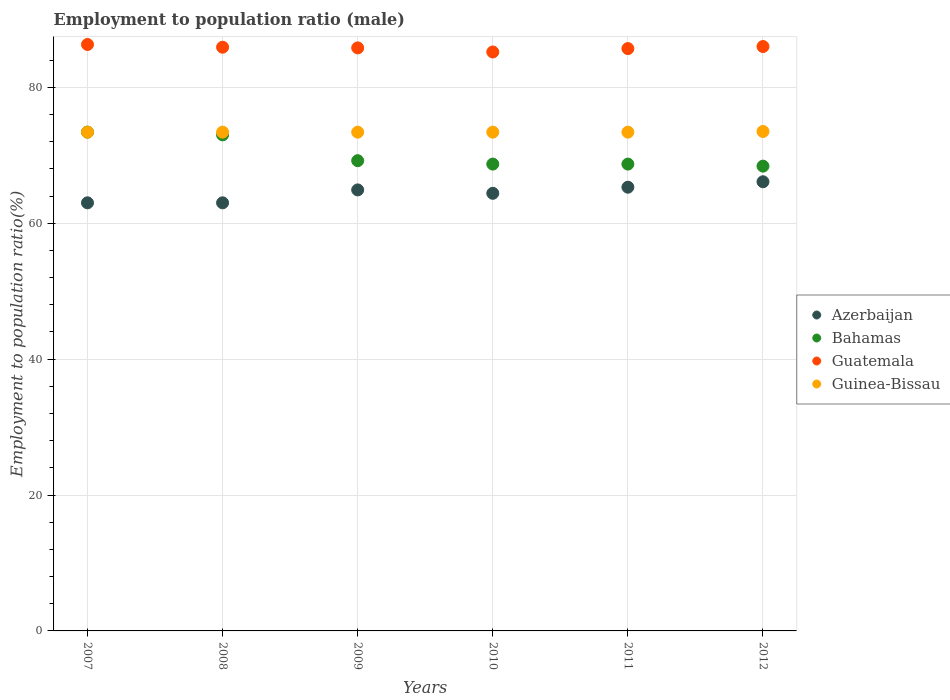Is the number of dotlines equal to the number of legend labels?
Your answer should be very brief. Yes. What is the employment to population ratio in Guatemala in 2008?
Keep it short and to the point. 85.9. Across all years, what is the maximum employment to population ratio in Guatemala?
Provide a succinct answer. 86.3. Across all years, what is the minimum employment to population ratio in Guinea-Bissau?
Give a very brief answer. 73.4. In which year was the employment to population ratio in Azerbaijan maximum?
Ensure brevity in your answer.  2012. In which year was the employment to population ratio in Azerbaijan minimum?
Your answer should be very brief. 2007. What is the total employment to population ratio in Bahamas in the graph?
Make the answer very short. 421.4. What is the difference between the employment to population ratio in Guinea-Bissau in 2007 and that in 2012?
Offer a terse response. -0.1. What is the difference between the employment to population ratio in Azerbaijan in 2010 and the employment to population ratio in Guatemala in 2008?
Ensure brevity in your answer.  -21.5. What is the average employment to population ratio in Azerbaijan per year?
Make the answer very short. 64.45. What is the ratio of the employment to population ratio in Azerbaijan in 2009 to that in 2012?
Offer a very short reply. 0.98. Is the employment to population ratio in Azerbaijan in 2009 less than that in 2011?
Your response must be concise. Yes. What is the difference between the highest and the second highest employment to population ratio in Guinea-Bissau?
Give a very brief answer. 0.1. What is the difference between the highest and the lowest employment to population ratio in Bahamas?
Your answer should be very brief. 5. Is the sum of the employment to population ratio in Guatemala in 2010 and 2012 greater than the maximum employment to population ratio in Guinea-Bissau across all years?
Offer a terse response. Yes. Is it the case that in every year, the sum of the employment to population ratio in Bahamas and employment to population ratio in Azerbaijan  is greater than the sum of employment to population ratio in Guinea-Bissau and employment to population ratio in Guatemala?
Ensure brevity in your answer.  No. Does the employment to population ratio in Bahamas monotonically increase over the years?
Your answer should be very brief. No. Is the employment to population ratio in Bahamas strictly less than the employment to population ratio in Azerbaijan over the years?
Give a very brief answer. No. How many dotlines are there?
Give a very brief answer. 4. How many years are there in the graph?
Make the answer very short. 6. What is the difference between two consecutive major ticks on the Y-axis?
Offer a terse response. 20. Where does the legend appear in the graph?
Provide a succinct answer. Center right. What is the title of the graph?
Your answer should be very brief. Employment to population ratio (male). What is the label or title of the Y-axis?
Offer a terse response. Employment to population ratio(%). What is the Employment to population ratio(%) of Azerbaijan in 2007?
Give a very brief answer. 63. What is the Employment to population ratio(%) in Bahamas in 2007?
Provide a succinct answer. 73.4. What is the Employment to population ratio(%) in Guatemala in 2007?
Provide a succinct answer. 86.3. What is the Employment to population ratio(%) of Guinea-Bissau in 2007?
Your answer should be compact. 73.4. What is the Employment to population ratio(%) of Azerbaijan in 2008?
Keep it short and to the point. 63. What is the Employment to population ratio(%) in Bahamas in 2008?
Provide a short and direct response. 73. What is the Employment to population ratio(%) in Guatemala in 2008?
Ensure brevity in your answer.  85.9. What is the Employment to population ratio(%) in Guinea-Bissau in 2008?
Your answer should be compact. 73.4. What is the Employment to population ratio(%) in Azerbaijan in 2009?
Provide a short and direct response. 64.9. What is the Employment to population ratio(%) in Bahamas in 2009?
Make the answer very short. 69.2. What is the Employment to population ratio(%) of Guatemala in 2009?
Give a very brief answer. 85.8. What is the Employment to population ratio(%) in Guinea-Bissau in 2009?
Keep it short and to the point. 73.4. What is the Employment to population ratio(%) in Azerbaijan in 2010?
Your answer should be compact. 64.4. What is the Employment to population ratio(%) of Bahamas in 2010?
Give a very brief answer. 68.7. What is the Employment to population ratio(%) in Guatemala in 2010?
Offer a terse response. 85.2. What is the Employment to population ratio(%) of Guinea-Bissau in 2010?
Make the answer very short. 73.4. What is the Employment to population ratio(%) of Azerbaijan in 2011?
Keep it short and to the point. 65.3. What is the Employment to population ratio(%) of Bahamas in 2011?
Keep it short and to the point. 68.7. What is the Employment to population ratio(%) of Guatemala in 2011?
Provide a succinct answer. 85.7. What is the Employment to population ratio(%) in Guinea-Bissau in 2011?
Give a very brief answer. 73.4. What is the Employment to population ratio(%) in Azerbaijan in 2012?
Ensure brevity in your answer.  66.1. What is the Employment to population ratio(%) of Bahamas in 2012?
Make the answer very short. 68.4. What is the Employment to population ratio(%) in Guatemala in 2012?
Give a very brief answer. 86. What is the Employment to population ratio(%) in Guinea-Bissau in 2012?
Keep it short and to the point. 73.5. Across all years, what is the maximum Employment to population ratio(%) of Azerbaijan?
Offer a very short reply. 66.1. Across all years, what is the maximum Employment to population ratio(%) of Bahamas?
Ensure brevity in your answer.  73.4. Across all years, what is the maximum Employment to population ratio(%) in Guatemala?
Your response must be concise. 86.3. Across all years, what is the maximum Employment to population ratio(%) of Guinea-Bissau?
Your response must be concise. 73.5. Across all years, what is the minimum Employment to population ratio(%) of Azerbaijan?
Offer a very short reply. 63. Across all years, what is the minimum Employment to population ratio(%) in Bahamas?
Offer a very short reply. 68.4. Across all years, what is the minimum Employment to population ratio(%) in Guatemala?
Provide a succinct answer. 85.2. Across all years, what is the minimum Employment to population ratio(%) in Guinea-Bissau?
Provide a short and direct response. 73.4. What is the total Employment to population ratio(%) in Azerbaijan in the graph?
Your answer should be compact. 386.7. What is the total Employment to population ratio(%) in Bahamas in the graph?
Provide a succinct answer. 421.4. What is the total Employment to population ratio(%) in Guatemala in the graph?
Your answer should be compact. 514.9. What is the total Employment to population ratio(%) of Guinea-Bissau in the graph?
Ensure brevity in your answer.  440.5. What is the difference between the Employment to population ratio(%) in Azerbaijan in 2007 and that in 2008?
Your answer should be very brief. 0. What is the difference between the Employment to population ratio(%) in Bahamas in 2007 and that in 2008?
Offer a terse response. 0.4. What is the difference between the Employment to population ratio(%) of Guatemala in 2007 and that in 2008?
Provide a succinct answer. 0.4. What is the difference between the Employment to population ratio(%) of Guinea-Bissau in 2007 and that in 2008?
Your response must be concise. 0. What is the difference between the Employment to population ratio(%) in Azerbaijan in 2007 and that in 2009?
Give a very brief answer. -1.9. What is the difference between the Employment to population ratio(%) in Bahamas in 2007 and that in 2009?
Ensure brevity in your answer.  4.2. What is the difference between the Employment to population ratio(%) of Azerbaijan in 2007 and that in 2010?
Ensure brevity in your answer.  -1.4. What is the difference between the Employment to population ratio(%) of Bahamas in 2007 and that in 2010?
Make the answer very short. 4.7. What is the difference between the Employment to population ratio(%) in Guatemala in 2007 and that in 2010?
Provide a short and direct response. 1.1. What is the difference between the Employment to population ratio(%) in Guinea-Bissau in 2007 and that in 2010?
Keep it short and to the point. 0. What is the difference between the Employment to population ratio(%) in Azerbaijan in 2007 and that in 2011?
Your response must be concise. -2.3. What is the difference between the Employment to population ratio(%) in Bahamas in 2007 and that in 2011?
Offer a terse response. 4.7. What is the difference between the Employment to population ratio(%) in Guatemala in 2007 and that in 2011?
Give a very brief answer. 0.6. What is the difference between the Employment to population ratio(%) of Guinea-Bissau in 2007 and that in 2011?
Your answer should be very brief. 0. What is the difference between the Employment to population ratio(%) in Bahamas in 2007 and that in 2012?
Provide a short and direct response. 5. What is the difference between the Employment to population ratio(%) of Guatemala in 2007 and that in 2012?
Offer a terse response. 0.3. What is the difference between the Employment to population ratio(%) of Bahamas in 2008 and that in 2009?
Give a very brief answer. 3.8. What is the difference between the Employment to population ratio(%) of Guatemala in 2008 and that in 2009?
Give a very brief answer. 0.1. What is the difference between the Employment to population ratio(%) in Azerbaijan in 2008 and that in 2010?
Offer a terse response. -1.4. What is the difference between the Employment to population ratio(%) in Bahamas in 2008 and that in 2010?
Ensure brevity in your answer.  4.3. What is the difference between the Employment to population ratio(%) in Guinea-Bissau in 2008 and that in 2010?
Offer a very short reply. 0. What is the difference between the Employment to population ratio(%) of Azerbaijan in 2008 and that in 2011?
Your answer should be compact. -2.3. What is the difference between the Employment to population ratio(%) in Bahamas in 2008 and that in 2011?
Ensure brevity in your answer.  4.3. What is the difference between the Employment to population ratio(%) of Guatemala in 2008 and that in 2011?
Make the answer very short. 0.2. What is the difference between the Employment to population ratio(%) of Guinea-Bissau in 2008 and that in 2011?
Your answer should be compact. 0. What is the difference between the Employment to population ratio(%) in Azerbaijan in 2008 and that in 2012?
Offer a very short reply. -3.1. What is the difference between the Employment to population ratio(%) in Bahamas in 2008 and that in 2012?
Offer a very short reply. 4.6. What is the difference between the Employment to population ratio(%) of Guinea-Bissau in 2008 and that in 2012?
Keep it short and to the point. -0.1. What is the difference between the Employment to population ratio(%) in Azerbaijan in 2009 and that in 2010?
Give a very brief answer. 0.5. What is the difference between the Employment to population ratio(%) of Bahamas in 2009 and that in 2010?
Offer a very short reply. 0.5. What is the difference between the Employment to population ratio(%) in Guatemala in 2009 and that in 2010?
Your response must be concise. 0.6. What is the difference between the Employment to population ratio(%) of Guinea-Bissau in 2009 and that in 2010?
Make the answer very short. 0. What is the difference between the Employment to population ratio(%) in Bahamas in 2009 and that in 2011?
Your answer should be very brief. 0.5. What is the difference between the Employment to population ratio(%) in Azerbaijan in 2009 and that in 2012?
Offer a very short reply. -1.2. What is the difference between the Employment to population ratio(%) in Guatemala in 2009 and that in 2012?
Provide a succinct answer. -0.2. What is the difference between the Employment to population ratio(%) of Azerbaijan in 2010 and that in 2012?
Offer a very short reply. -1.7. What is the difference between the Employment to population ratio(%) in Bahamas in 2010 and that in 2012?
Provide a short and direct response. 0.3. What is the difference between the Employment to population ratio(%) in Guatemala in 2010 and that in 2012?
Make the answer very short. -0.8. What is the difference between the Employment to population ratio(%) in Guinea-Bissau in 2010 and that in 2012?
Your response must be concise. -0.1. What is the difference between the Employment to population ratio(%) of Guatemala in 2011 and that in 2012?
Offer a very short reply. -0.3. What is the difference between the Employment to population ratio(%) in Guinea-Bissau in 2011 and that in 2012?
Offer a terse response. -0.1. What is the difference between the Employment to population ratio(%) of Azerbaijan in 2007 and the Employment to population ratio(%) of Guatemala in 2008?
Provide a short and direct response. -22.9. What is the difference between the Employment to population ratio(%) in Azerbaijan in 2007 and the Employment to population ratio(%) in Bahamas in 2009?
Offer a very short reply. -6.2. What is the difference between the Employment to population ratio(%) of Azerbaijan in 2007 and the Employment to population ratio(%) of Guatemala in 2009?
Provide a succinct answer. -22.8. What is the difference between the Employment to population ratio(%) of Azerbaijan in 2007 and the Employment to population ratio(%) of Guinea-Bissau in 2009?
Provide a short and direct response. -10.4. What is the difference between the Employment to population ratio(%) of Bahamas in 2007 and the Employment to population ratio(%) of Guatemala in 2009?
Offer a very short reply. -12.4. What is the difference between the Employment to population ratio(%) in Guatemala in 2007 and the Employment to population ratio(%) in Guinea-Bissau in 2009?
Give a very brief answer. 12.9. What is the difference between the Employment to population ratio(%) of Azerbaijan in 2007 and the Employment to population ratio(%) of Guatemala in 2010?
Give a very brief answer. -22.2. What is the difference between the Employment to population ratio(%) in Azerbaijan in 2007 and the Employment to population ratio(%) in Guinea-Bissau in 2010?
Offer a terse response. -10.4. What is the difference between the Employment to population ratio(%) of Azerbaijan in 2007 and the Employment to population ratio(%) of Bahamas in 2011?
Your response must be concise. -5.7. What is the difference between the Employment to population ratio(%) of Azerbaijan in 2007 and the Employment to population ratio(%) of Guatemala in 2011?
Offer a very short reply. -22.7. What is the difference between the Employment to population ratio(%) in Azerbaijan in 2007 and the Employment to population ratio(%) in Guinea-Bissau in 2011?
Offer a very short reply. -10.4. What is the difference between the Employment to population ratio(%) of Bahamas in 2007 and the Employment to population ratio(%) of Guatemala in 2011?
Your response must be concise. -12.3. What is the difference between the Employment to population ratio(%) in Guatemala in 2007 and the Employment to population ratio(%) in Guinea-Bissau in 2011?
Keep it short and to the point. 12.9. What is the difference between the Employment to population ratio(%) of Azerbaijan in 2007 and the Employment to population ratio(%) of Bahamas in 2012?
Your answer should be compact. -5.4. What is the difference between the Employment to population ratio(%) in Azerbaijan in 2007 and the Employment to population ratio(%) in Guatemala in 2012?
Give a very brief answer. -23. What is the difference between the Employment to population ratio(%) of Azerbaijan in 2007 and the Employment to population ratio(%) of Guinea-Bissau in 2012?
Keep it short and to the point. -10.5. What is the difference between the Employment to population ratio(%) of Guatemala in 2007 and the Employment to population ratio(%) of Guinea-Bissau in 2012?
Your answer should be compact. 12.8. What is the difference between the Employment to population ratio(%) of Azerbaijan in 2008 and the Employment to population ratio(%) of Guatemala in 2009?
Your answer should be very brief. -22.8. What is the difference between the Employment to population ratio(%) of Bahamas in 2008 and the Employment to population ratio(%) of Guatemala in 2009?
Your answer should be very brief. -12.8. What is the difference between the Employment to population ratio(%) in Guatemala in 2008 and the Employment to population ratio(%) in Guinea-Bissau in 2009?
Offer a terse response. 12.5. What is the difference between the Employment to population ratio(%) of Azerbaijan in 2008 and the Employment to population ratio(%) of Bahamas in 2010?
Provide a short and direct response. -5.7. What is the difference between the Employment to population ratio(%) in Azerbaijan in 2008 and the Employment to population ratio(%) in Guatemala in 2010?
Give a very brief answer. -22.2. What is the difference between the Employment to population ratio(%) in Bahamas in 2008 and the Employment to population ratio(%) in Guatemala in 2010?
Your answer should be compact. -12.2. What is the difference between the Employment to population ratio(%) in Bahamas in 2008 and the Employment to population ratio(%) in Guinea-Bissau in 2010?
Provide a succinct answer. -0.4. What is the difference between the Employment to population ratio(%) in Guatemala in 2008 and the Employment to population ratio(%) in Guinea-Bissau in 2010?
Your answer should be very brief. 12.5. What is the difference between the Employment to population ratio(%) in Azerbaijan in 2008 and the Employment to population ratio(%) in Bahamas in 2011?
Provide a short and direct response. -5.7. What is the difference between the Employment to population ratio(%) of Azerbaijan in 2008 and the Employment to population ratio(%) of Guatemala in 2011?
Your response must be concise. -22.7. What is the difference between the Employment to population ratio(%) of Bahamas in 2008 and the Employment to population ratio(%) of Guatemala in 2011?
Provide a short and direct response. -12.7. What is the difference between the Employment to population ratio(%) of Bahamas in 2008 and the Employment to population ratio(%) of Guinea-Bissau in 2011?
Your response must be concise. -0.4. What is the difference between the Employment to population ratio(%) of Azerbaijan in 2008 and the Employment to population ratio(%) of Bahamas in 2012?
Provide a succinct answer. -5.4. What is the difference between the Employment to population ratio(%) of Bahamas in 2008 and the Employment to population ratio(%) of Guatemala in 2012?
Offer a terse response. -13. What is the difference between the Employment to population ratio(%) of Bahamas in 2008 and the Employment to population ratio(%) of Guinea-Bissau in 2012?
Keep it short and to the point. -0.5. What is the difference between the Employment to population ratio(%) in Guatemala in 2008 and the Employment to population ratio(%) in Guinea-Bissau in 2012?
Keep it short and to the point. 12.4. What is the difference between the Employment to population ratio(%) of Azerbaijan in 2009 and the Employment to population ratio(%) of Bahamas in 2010?
Your response must be concise. -3.8. What is the difference between the Employment to population ratio(%) of Azerbaijan in 2009 and the Employment to population ratio(%) of Guatemala in 2010?
Give a very brief answer. -20.3. What is the difference between the Employment to population ratio(%) of Bahamas in 2009 and the Employment to population ratio(%) of Guatemala in 2010?
Provide a succinct answer. -16. What is the difference between the Employment to population ratio(%) of Azerbaijan in 2009 and the Employment to population ratio(%) of Bahamas in 2011?
Ensure brevity in your answer.  -3.8. What is the difference between the Employment to population ratio(%) of Azerbaijan in 2009 and the Employment to population ratio(%) of Guatemala in 2011?
Provide a short and direct response. -20.8. What is the difference between the Employment to population ratio(%) of Bahamas in 2009 and the Employment to population ratio(%) of Guatemala in 2011?
Make the answer very short. -16.5. What is the difference between the Employment to population ratio(%) in Azerbaijan in 2009 and the Employment to population ratio(%) in Guatemala in 2012?
Offer a terse response. -21.1. What is the difference between the Employment to population ratio(%) of Azerbaijan in 2009 and the Employment to population ratio(%) of Guinea-Bissau in 2012?
Your answer should be compact. -8.6. What is the difference between the Employment to population ratio(%) of Bahamas in 2009 and the Employment to population ratio(%) of Guatemala in 2012?
Ensure brevity in your answer.  -16.8. What is the difference between the Employment to population ratio(%) of Guatemala in 2009 and the Employment to population ratio(%) of Guinea-Bissau in 2012?
Keep it short and to the point. 12.3. What is the difference between the Employment to population ratio(%) in Azerbaijan in 2010 and the Employment to population ratio(%) in Guatemala in 2011?
Your answer should be very brief. -21.3. What is the difference between the Employment to population ratio(%) in Azerbaijan in 2010 and the Employment to population ratio(%) in Guinea-Bissau in 2011?
Your answer should be compact. -9. What is the difference between the Employment to population ratio(%) of Bahamas in 2010 and the Employment to population ratio(%) of Guinea-Bissau in 2011?
Give a very brief answer. -4.7. What is the difference between the Employment to population ratio(%) of Azerbaijan in 2010 and the Employment to population ratio(%) of Bahamas in 2012?
Make the answer very short. -4. What is the difference between the Employment to population ratio(%) of Azerbaijan in 2010 and the Employment to population ratio(%) of Guatemala in 2012?
Give a very brief answer. -21.6. What is the difference between the Employment to population ratio(%) in Azerbaijan in 2010 and the Employment to population ratio(%) in Guinea-Bissau in 2012?
Offer a terse response. -9.1. What is the difference between the Employment to population ratio(%) in Bahamas in 2010 and the Employment to population ratio(%) in Guatemala in 2012?
Keep it short and to the point. -17.3. What is the difference between the Employment to population ratio(%) of Azerbaijan in 2011 and the Employment to population ratio(%) of Guatemala in 2012?
Provide a succinct answer. -20.7. What is the difference between the Employment to population ratio(%) of Bahamas in 2011 and the Employment to population ratio(%) of Guatemala in 2012?
Make the answer very short. -17.3. What is the difference between the Employment to population ratio(%) of Guatemala in 2011 and the Employment to population ratio(%) of Guinea-Bissau in 2012?
Provide a short and direct response. 12.2. What is the average Employment to population ratio(%) in Azerbaijan per year?
Provide a short and direct response. 64.45. What is the average Employment to population ratio(%) in Bahamas per year?
Ensure brevity in your answer.  70.23. What is the average Employment to population ratio(%) of Guatemala per year?
Keep it short and to the point. 85.82. What is the average Employment to population ratio(%) of Guinea-Bissau per year?
Give a very brief answer. 73.42. In the year 2007, what is the difference between the Employment to population ratio(%) in Azerbaijan and Employment to population ratio(%) in Guatemala?
Your answer should be very brief. -23.3. In the year 2008, what is the difference between the Employment to population ratio(%) of Azerbaijan and Employment to population ratio(%) of Bahamas?
Your answer should be compact. -10. In the year 2008, what is the difference between the Employment to population ratio(%) in Azerbaijan and Employment to population ratio(%) in Guatemala?
Your answer should be compact. -22.9. In the year 2008, what is the difference between the Employment to population ratio(%) in Bahamas and Employment to population ratio(%) in Guinea-Bissau?
Offer a very short reply. -0.4. In the year 2008, what is the difference between the Employment to population ratio(%) in Guatemala and Employment to population ratio(%) in Guinea-Bissau?
Provide a short and direct response. 12.5. In the year 2009, what is the difference between the Employment to population ratio(%) in Azerbaijan and Employment to population ratio(%) in Bahamas?
Give a very brief answer. -4.3. In the year 2009, what is the difference between the Employment to population ratio(%) in Azerbaijan and Employment to population ratio(%) in Guatemala?
Offer a very short reply. -20.9. In the year 2009, what is the difference between the Employment to population ratio(%) of Bahamas and Employment to population ratio(%) of Guatemala?
Give a very brief answer. -16.6. In the year 2009, what is the difference between the Employment to population ratio(%) of Guatemala and Employment to population ratio(%) of Guinea-Bissau?
Offer a very short reply. 12.4. In the year 2010, what is the difference between the Employment to population ratio(%) in Azerbaijan and Employment to population ratio(%) in Bahamas?
Your answer should be compact. -4.3. In the year 2010, what is the difference between the Employment to population ratio(%) of Azerbaijan and Employment to population ratio(%) of Guatemala?
Your answer should be compact. -20.8. In the year 2010, what is the difference between the Employment to population ratio(%) in Azerbaijan and Employment to population ratio(%) in Guinea-Bissau?
Ensure brevity in your answer.  -9. In the year 2010, what is the difference between the Employment to population ratio(%) of Bahamas and Employment to population ratio(%) of Guatemala?
Give a very brief answer. -16.5. In the year 2010, what is the difference between the Employment to population ratio(%) of Bahamas and Employment to population ratio(%) of Guinea-Bissau?
Your answer should be compact. -4.7. In the year 2010, what is the difference between the Employment to population ratio(%) in Guatemala and Employment to population ratio(%) in Guinea-Bissau?
Give a very brief answer. 11.8. In the year 2011, what is the difference between the Employment to population ratio(%) of Azerbaijan and Employment to population ratio(%) of Guatemala?
Make the answer very short. -20.4. In the year 2011, what is the difference between the Employment to population ratio(%) in Azerbaijan and Employment to population ratio(%) in Guinea-Bissau?
Your response must be concise. -8.1. In the year 2011, what is the difference between the Employment to population ratio(%) of Bahamas and Employment to population ratio(%) of Guatemala?
Keep it short and to the point. -17. In the year 2012, what is the difference between the Employment to population ratio(%) of Azerbaijan and Employment to population ratio(%) of Guatemala?
Provide a succinct answer. -19.9. In the year 2012, what is the difference between the Employment to population ratio(%) in Azerbaijan and Employment to population ratio(%) in Guinea-Bissau?
Keep it short and to the point. -7.4. In the year 2012, what is the difference between the Employment to population ratio(%) in Bahamas and Employment to population ratio(%) in Guatemala?
Offer a very short reply. -17.6. In the year 2012, what is the difference between the Employment to population ratio(%) in Bahamas and Employment to population ratio(%) in Guinea-Bissau?
Make the answer very short. -5.1. What is the ratio of the Employment to population ratio(%) in Guinea-Bissau in 2007 to that in 2008?
Your answer should be very brief. 1. What is the ratio of the Employment to population ratio(%) of Azerbaijan in 2007 to that in 2009?
Your response must be concise. 0.97. What is the ratio of the Employment to population ratio(%) of Bahamas in 2007 to that in 2009?
Your answer should be very brief. 1.06. What is the ratio of the Employment to population ratio(%) of Azerbaijan in 2007 to that in 2010?
Keep it short and to the point. 0.98. What is the ratio of the Employment to population ratio(%) of Bahamas in 2007 to that in 2010?
Your response must be concise. 1.07. What is the ratio of the Employment to population ratio(%) of Guatemala in 2007 to that in 2010?
Your answer should be compact. 1.01. What is the ratio of the Employment to population ratio(%) of Guinea-Bissau in 2007 to that in 2010?
Your answer should be very brief. 1. What is the ratio of the Employment to population ratio(%) of Azerbaijan in 2007 to that in 2011?
Give a very brief answer. 0.96. What is the ratio of the Employment to population ratio(%) in Bahamas in 2007 to that in 2011?
Your response must be concise. 1.07. What is the ratio of the Employment to population ratio(%) in Guatemala in 2007 to that in 2011?
Offer a terse response. 1.01. What is the ratio of the Employment to population ratio(%) in Guinea-Bissau in 2007 to that in 2011?
Your answer should be compact. 1. What is the ratio of the Employment to population ratio(%) of Azerbaijan in 2007 to that in 2012?
Your answer should be compact. 0.95. What is the ratio of the Employment to population ratio(%) in Bahamas in 2007 to that in 2012?
Keep it short and to the point. 1.07. What is the ratio of the Employment to population ratio(%) in Azerbaijan in 2008 to that in 2009?
Provide a short and direct response. 0.97. What is the ratio of the Employment to population ratio(%) of Bahamas in 2008 to that in 2009?
Make the answer very short. 1.05. What is the ratio of the Employment to population ratio(%) of Guinea-Bissau in 2008 to that in 2009?
Ensure brevity in your answer.  1. What is the ratio of the Employment to population ratio(%) of Azerbaijan in 2008 to that in 2010?
Your response must be concise. 0.98. What is the ratio of the Employment to population ratio(%) of Bahamas in 2008 to that in 2010?
Offer a terse response. 1.06. What is the ratio of the Employment to population ratio(%) of Guatemala in 2008 to that in 2010?
Your answer should be compact. 1.01. What is the ratio of the Employment to population ratio(%) in Azerbaijan in 2008 to that in 2011?
Offer a terse response. 0.96. What is the ratio of the Employment to population ratio(%) of Bahamas in 2008 to that in 2011?
Provide a short and direct response. 1.06. What is the ratio of the Employment to population ratio(%) in Guatemala in 2008 to that in 2011?
Keep it short and to the point. 1. What is the ratio of the Employment to population ratio(%) of Guinea-Bissau in 2008 to that in 2011?
Keep it short and to the point. 1. What is the ratio of the Employment to population ratio(%) in Azerbaijan in 2008 to that in 2012?
Give a very brief answer. 0.95. What is the ratio of the Employment to population ratio(%) in Bahamas in 2008 to that in 2012?
Make the answer very short. 1.07. What is the ratio of the Employment to population ratio(%) in Bahamas in 2009 to that in 2010?
Give a very brief answer. 1.01. What is the ratio of the Employment to population ratio(%) of Guatemala in 2009 to that in 2010?
Offer a terse response. 1.01. What is the ratio of the Employment to population ratio(%) in Guinea-Bissau in 2009 to that in 2010?
Give a very brief answer. 1. What is the ratio of the Employment to population ratio(%) in Azerbaijan in 2009 to that in 2011?
Make the answer very short. 0.99. What is the ratio of the Employment to population ratio(%) in Bahamas in 2009 to that in 2011?
Provide a short and direct response. 1.01. What is the ratio of the Employment to population ratio(%) of Azerbaijan in 2009 to that in 2012?
Provide a short and direct response. 0.98. What is the ratio of the Employment to population ratio(%) of Bahamas in 2009 to that in 2012?
Provide a short and direct response. 1.01. What is the ratio of the Employment to population ratio(%) in Guatemala in 2009 to that in 2012?
Give a very brief answer. 1. What is the ratio of the Employment to population ratio(%) in Azerbaijan in 2010 to that in 2011?
Your answer should be compact. 0.99. What is the ratio of the Employment to population ratio(%) of Guinea-Bissau in 2010 to that in 2011?
Your response must be concise. 1. What is the ratio of the Employment to population ratio(%) in Azerbaijan in 2010 to that in 2012?
Ensure brevity in your answer.  0.97. What is the ratio of the Employment to population ratio(%) of Bahamas in 2010 to that in 2012?
Provide a short and direct response. 1. What is the ratio of the Employment to population ratio(%) of Guatemala in 2010 to that in 2012?
Your answer should be compact. 0.99. What is the ratio of the Employment to population ratio(%) in Guinea-Bissau in 2010 to that in 2012?
Give a very brief answer. 1. What is the ratio of the Employment to population ratio(%) in Azerbaijan in 2011 to that in 2012?
Your answer should be compact. 0.99. What is the ratio of the Employment to population ratio(%) of Bahamas in 2011 to that in 2012?
Give a very brief answer. 1. What is the ratio of the Employment to population ratio(%) of Guatemala in 2011 to that in 2012?
Keep it short and to the point. 1. What is the difference between the highest and the second highest Employment to population ratio(%) of Bahamas?
Keep it short and to the point. 0.4. What is the difference between the highest and the second highest Employment to population ratio(%) of Guinea-Bissau?
Give a very brief answer. 0.1. What is the difference between the highest and the lowest Employment to population ratio(%) in Bahamas?
Provide a short and direct response. 5. What is the difference between the highest and the lowest Employment to population ratio(%) in Guinea-Bissau?
Give a very brief answer. 0.1. 